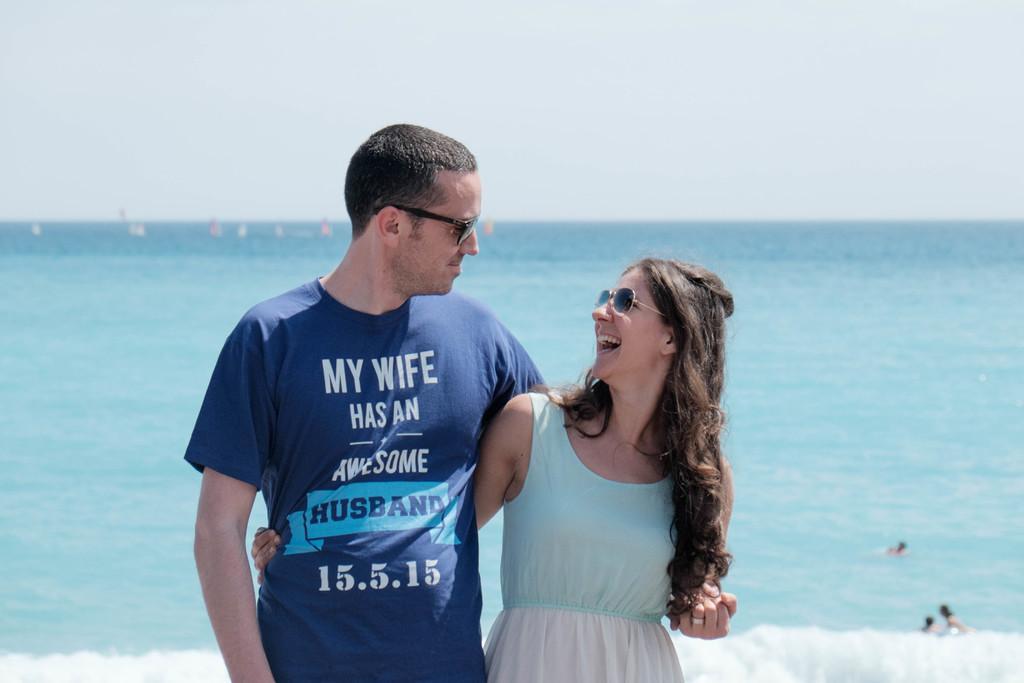Can you describe this image briefly? In this image I can see two persons standing. The person at right is wearing blue and white color dress and the person at left is wearing blue color shirt. In the background I can see the water and the sky is in white color. 